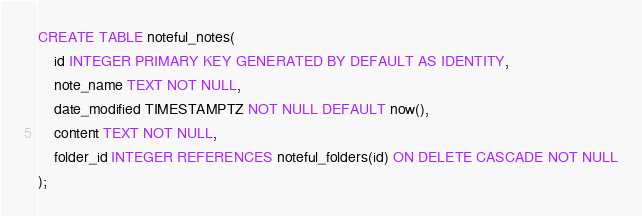Convert code to text. <code><loc_0><loc_0><loc_500><loc_500><_SQL_>CREATE TABLE noteful_notes(
    id INTEGER PRIMARY KEY GENERATED BY DEFAULT AS IDENTITY,
    note_name TEXT NOT NULL,
    date_modified TIMESTAMPTZ NOT NULL DEFAULT now(),
    content TEXT NOT NULL,
    folder_id INTEGER REFERENCES noteful_folders(id) ON DELETE CASCADE NOT NULL
);</code> 